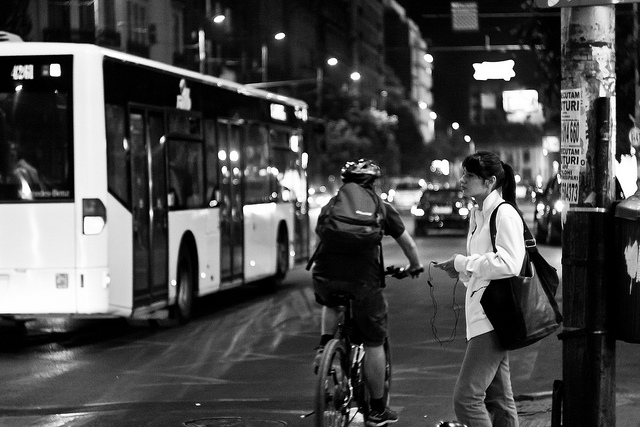<image>What bus is the lady waiting for? It is unknown for which bus the lady is waiting. What bus is the lady waiting for? I don't know which bus the lady is waiting for. It could be a city bus, a black bus, the next one, or the one that takes her home. 